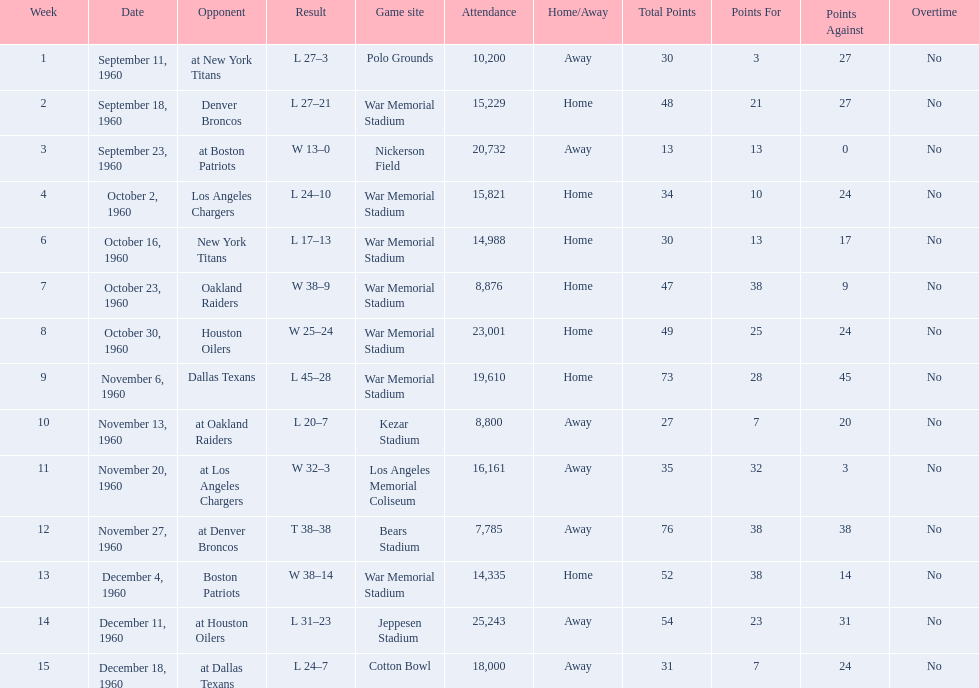Who was the opponent during for first week? New York Titans. 